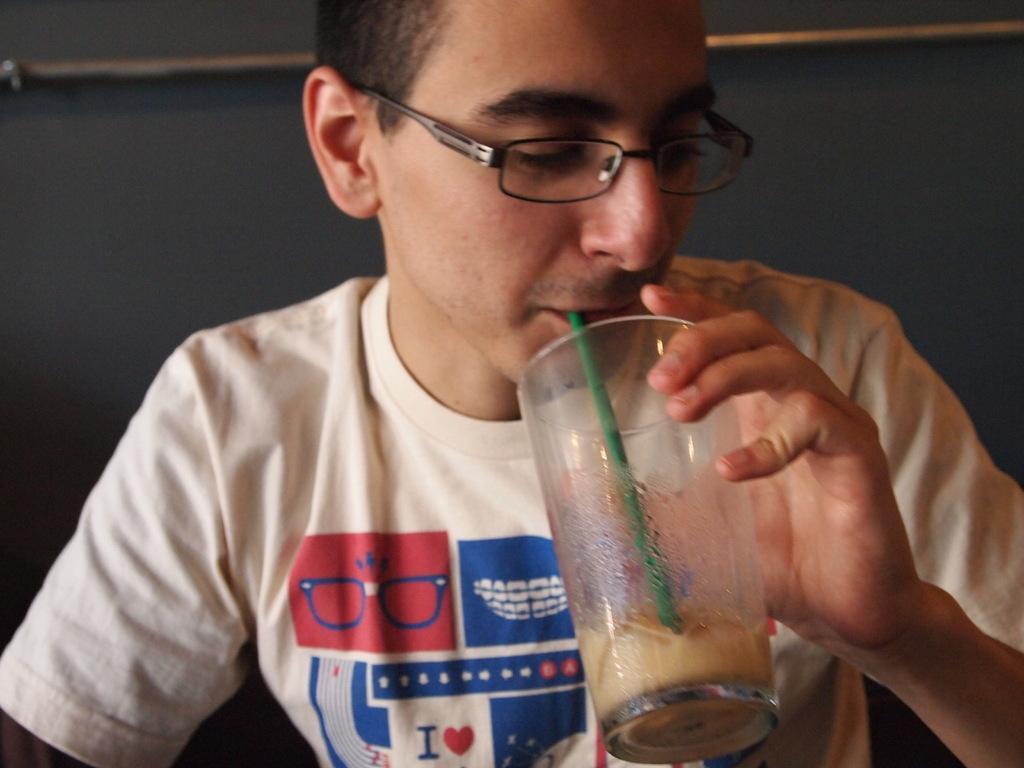Could you give a brief overview of what you see in this image? In this picture there is a person with white t-shirt is holding the glass and drinking and there is drink and straw in the glass. At the back it looks like a wall and there is a rod on the wall. 